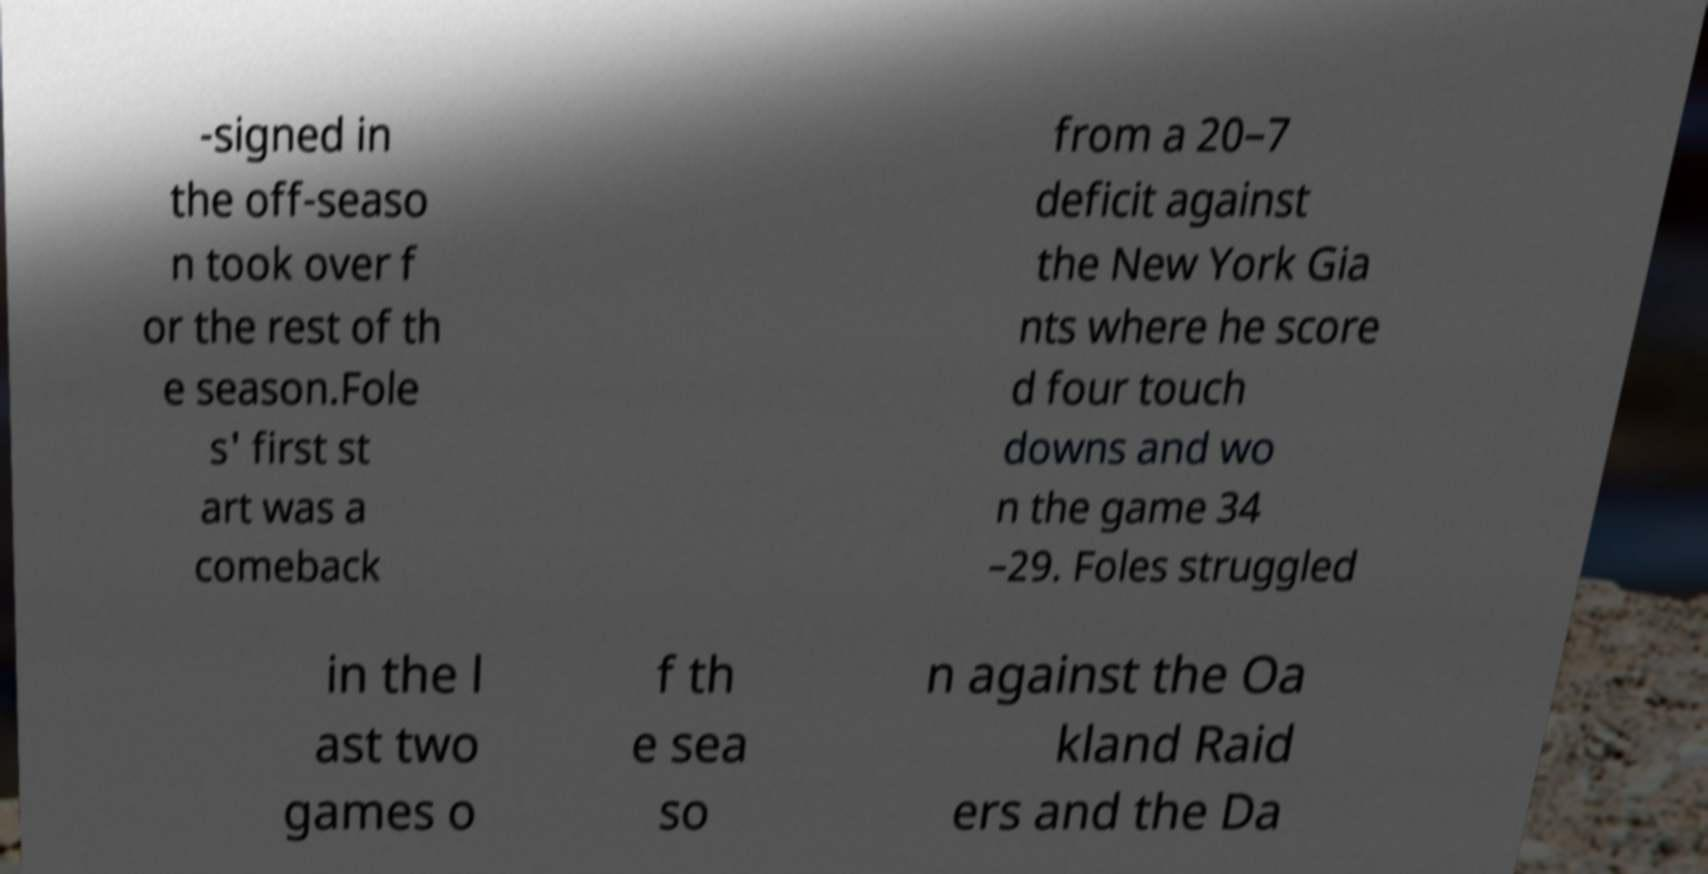I need the written content from this picture converted into text. Can you do that? -signed in the off-seaso n took over f or the rest of th e season.Fole s' first st art was a comeback from a 20–7 deficit against the New York Gia nts where he score d four touch downs and wo n the game 34 –29. Foles struggled in the l ast two games o f th e sea so n against the Oa kland Raid ers and the Da 